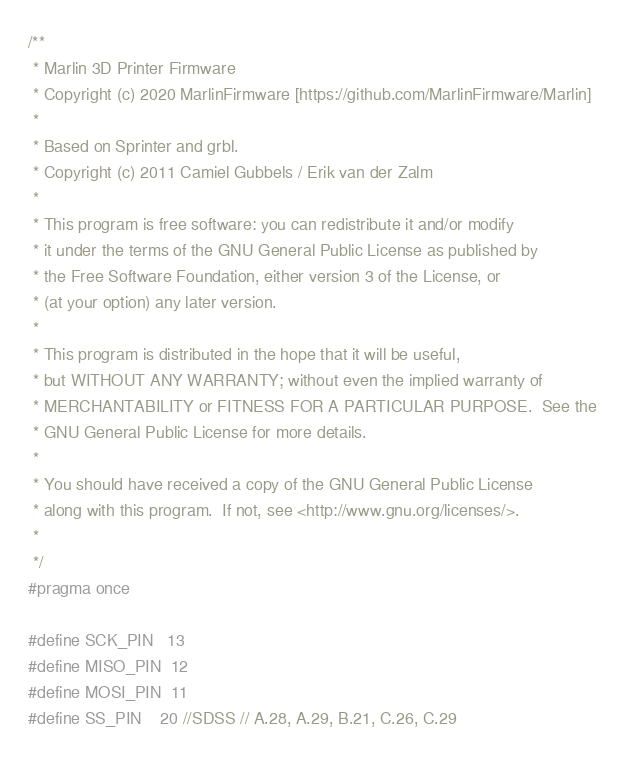<code> <loc_0><loc_0><loc_500><loc_500><_C_>/**
 * Marlin 3D Printer Firmware
 * Copyright (c) 2020 MarlinFirmware [https://github.com/MarlinFirmware/Marlin]
 *
 * Based on Sprinter and grbl.
 * Copyright (c) 2011 Camiel Gubbels / Erik van der Zalm
 *
 * This program is free software: you can redistribute it and/or modify
 * it under the terms of the GNU General Public License as published by
 * the Free Software Foundation, either version 3 of the License, or
 * (at your option) any later version.
 *
 * This program is distributed in the hope that it will be useful,
 * but WITHOUT ANY WARRANTY; without even the implied warranty of
 * MERCHANTABILITY or FITNESS FOR A PARTICULAR PURPOSE.  See the
 * GNU General Public License for more details.
 *
 * You should have received a copy of the GNU General Public License
 * along with this program.  If not, see <http://www.gnu.org/licenses/>.
 *
 */
#pragma once

#define SCK_PIN   13
#define MISO_PIN  12
#define MOSI_PIN  11
#define SS_PIN    20 //SDSS // A.28, A.29, B.21, C.26, C.29
</code> 